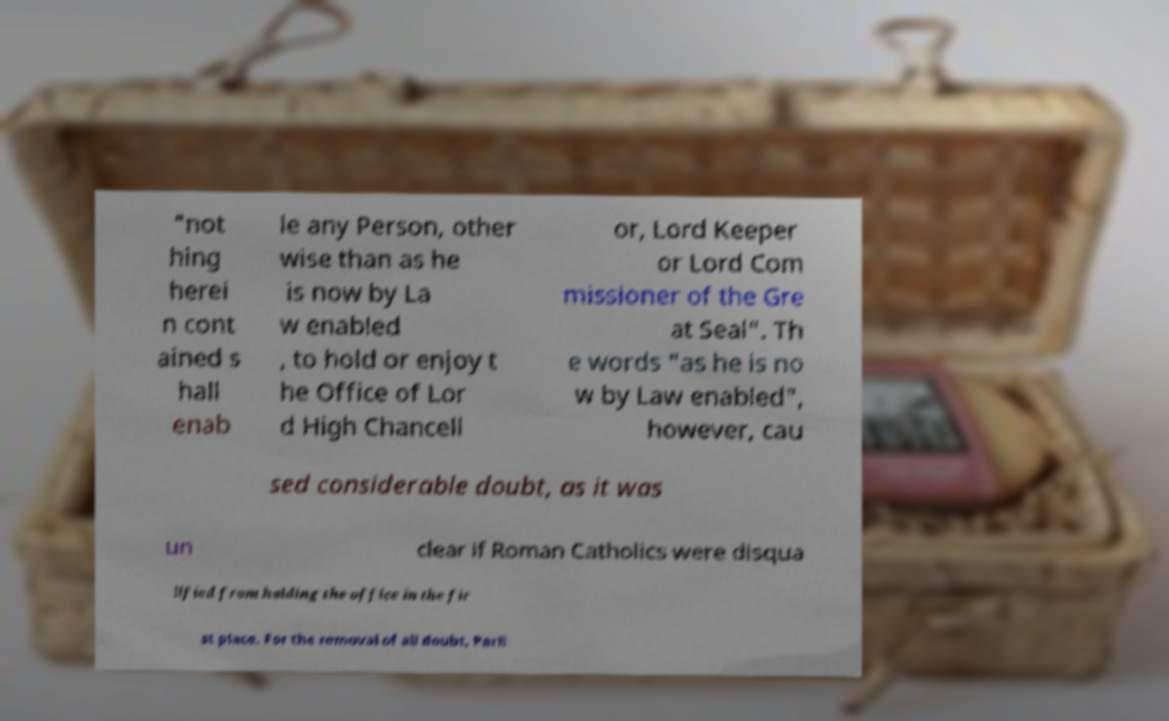Could you extract and type out the text from this image? "not hing herei n cont ained s hall enab le any Person, other wise than as he is now by La w enabled , to hold or enjoy t he Office of Lor d High Chancell or, Lord Keeper or Lord Com missioner of the Gre at Seal". Th e words "as he is no w by Law enabled", however, cau sed considerable doubt, as it was un clear if Roman Catholics were disqua lified from holding the office in the fir st place. For the removal of all doubt, Parli 